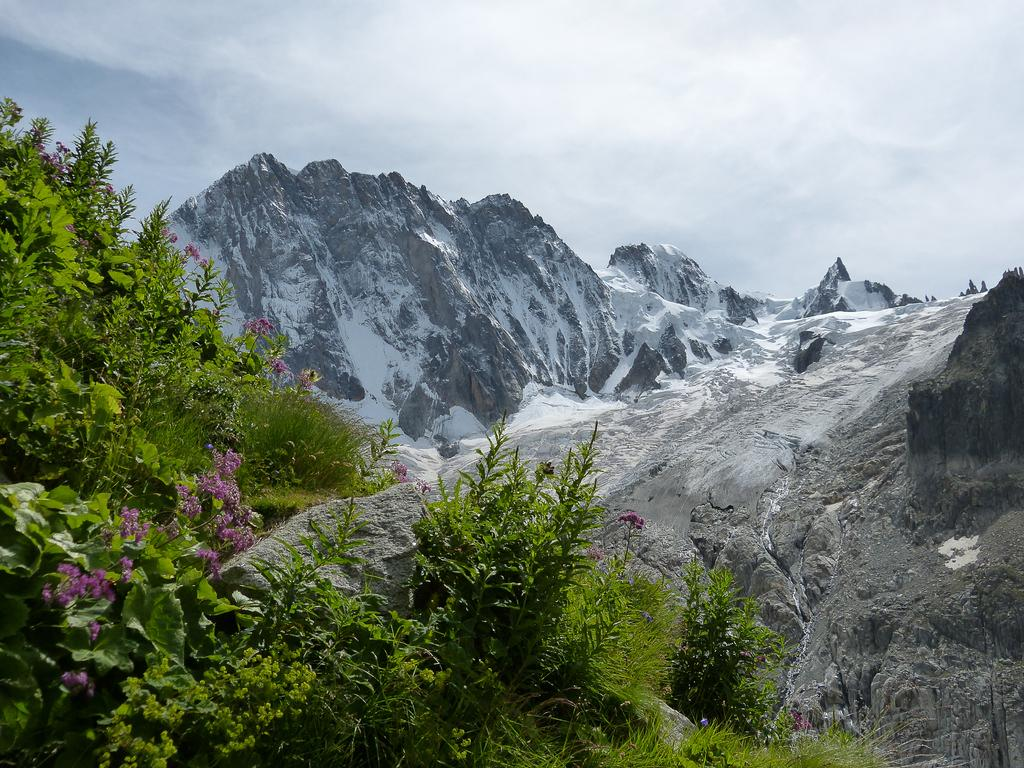What type of vegetation is present in the front of the image? There are floral plants in the front of the image. What type of natural formation can be seen in the image? There are mountains in the image. What is the condition of the mountains? The mountains are covered with snow. Where are the mountains located in the image? The mountains are at the back of the image. What is visible at the top of the image? The sky is visible at the top of the image. What type of gold can be seen shining in the image? There is no gold present in the image. What type of cabbage is growing on the mountains in the image? There are no cabbages present in the image; the mountains are covered with snow. 